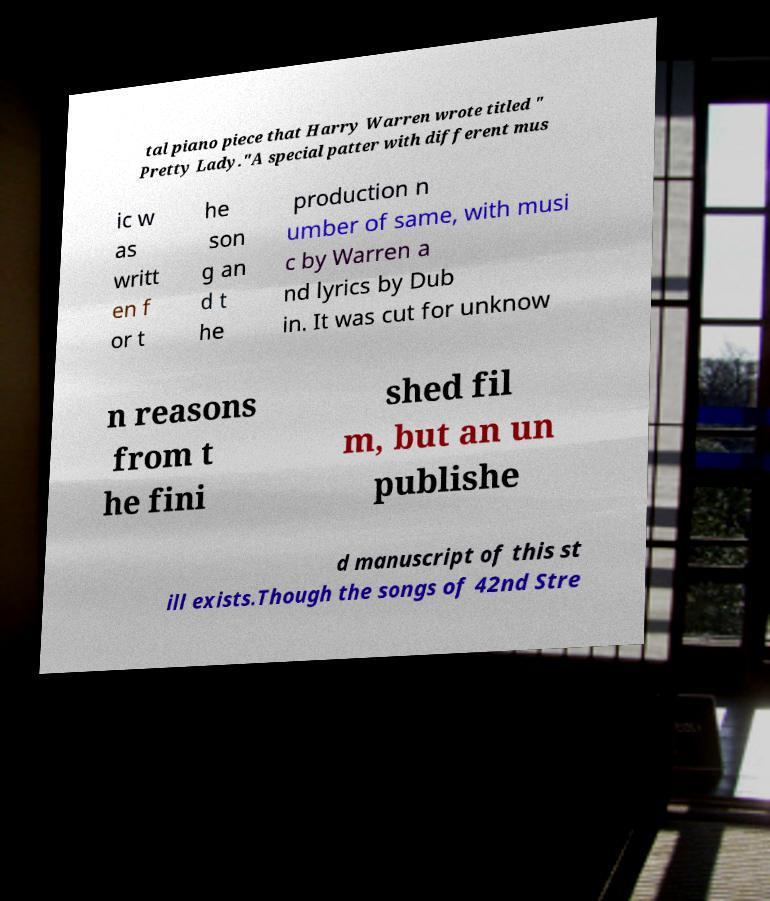I need the written content from this picture converted into text. Can you do that? tal piano piece that Harry Warren wrote titled " Pretty Lady."A special patter with different mus ic w as writt en f or t he son g an d t he production n umber of same, with musi c by Warren a nd lyrics by Dub in. It was cut for unknow n reasons from t he fini shed fil m, but an un publishe d manuscript of this st ill exists.Though the songs of 42nd Stre 